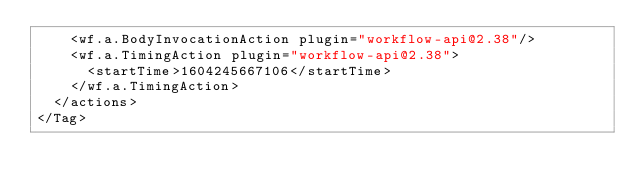<code> <loc_0><loc_0><loc_500><loc_500><_XML_>    <wf.a.BodyInvocationAction plugin="workflow-api@2.38"/>
    <wf.a.TimingAction plugin="workflow-api@2.38">
      <startTime>1604245667106</startTime>
    </wf.a.TimingAction>
  </actions>
</Tag></code> 